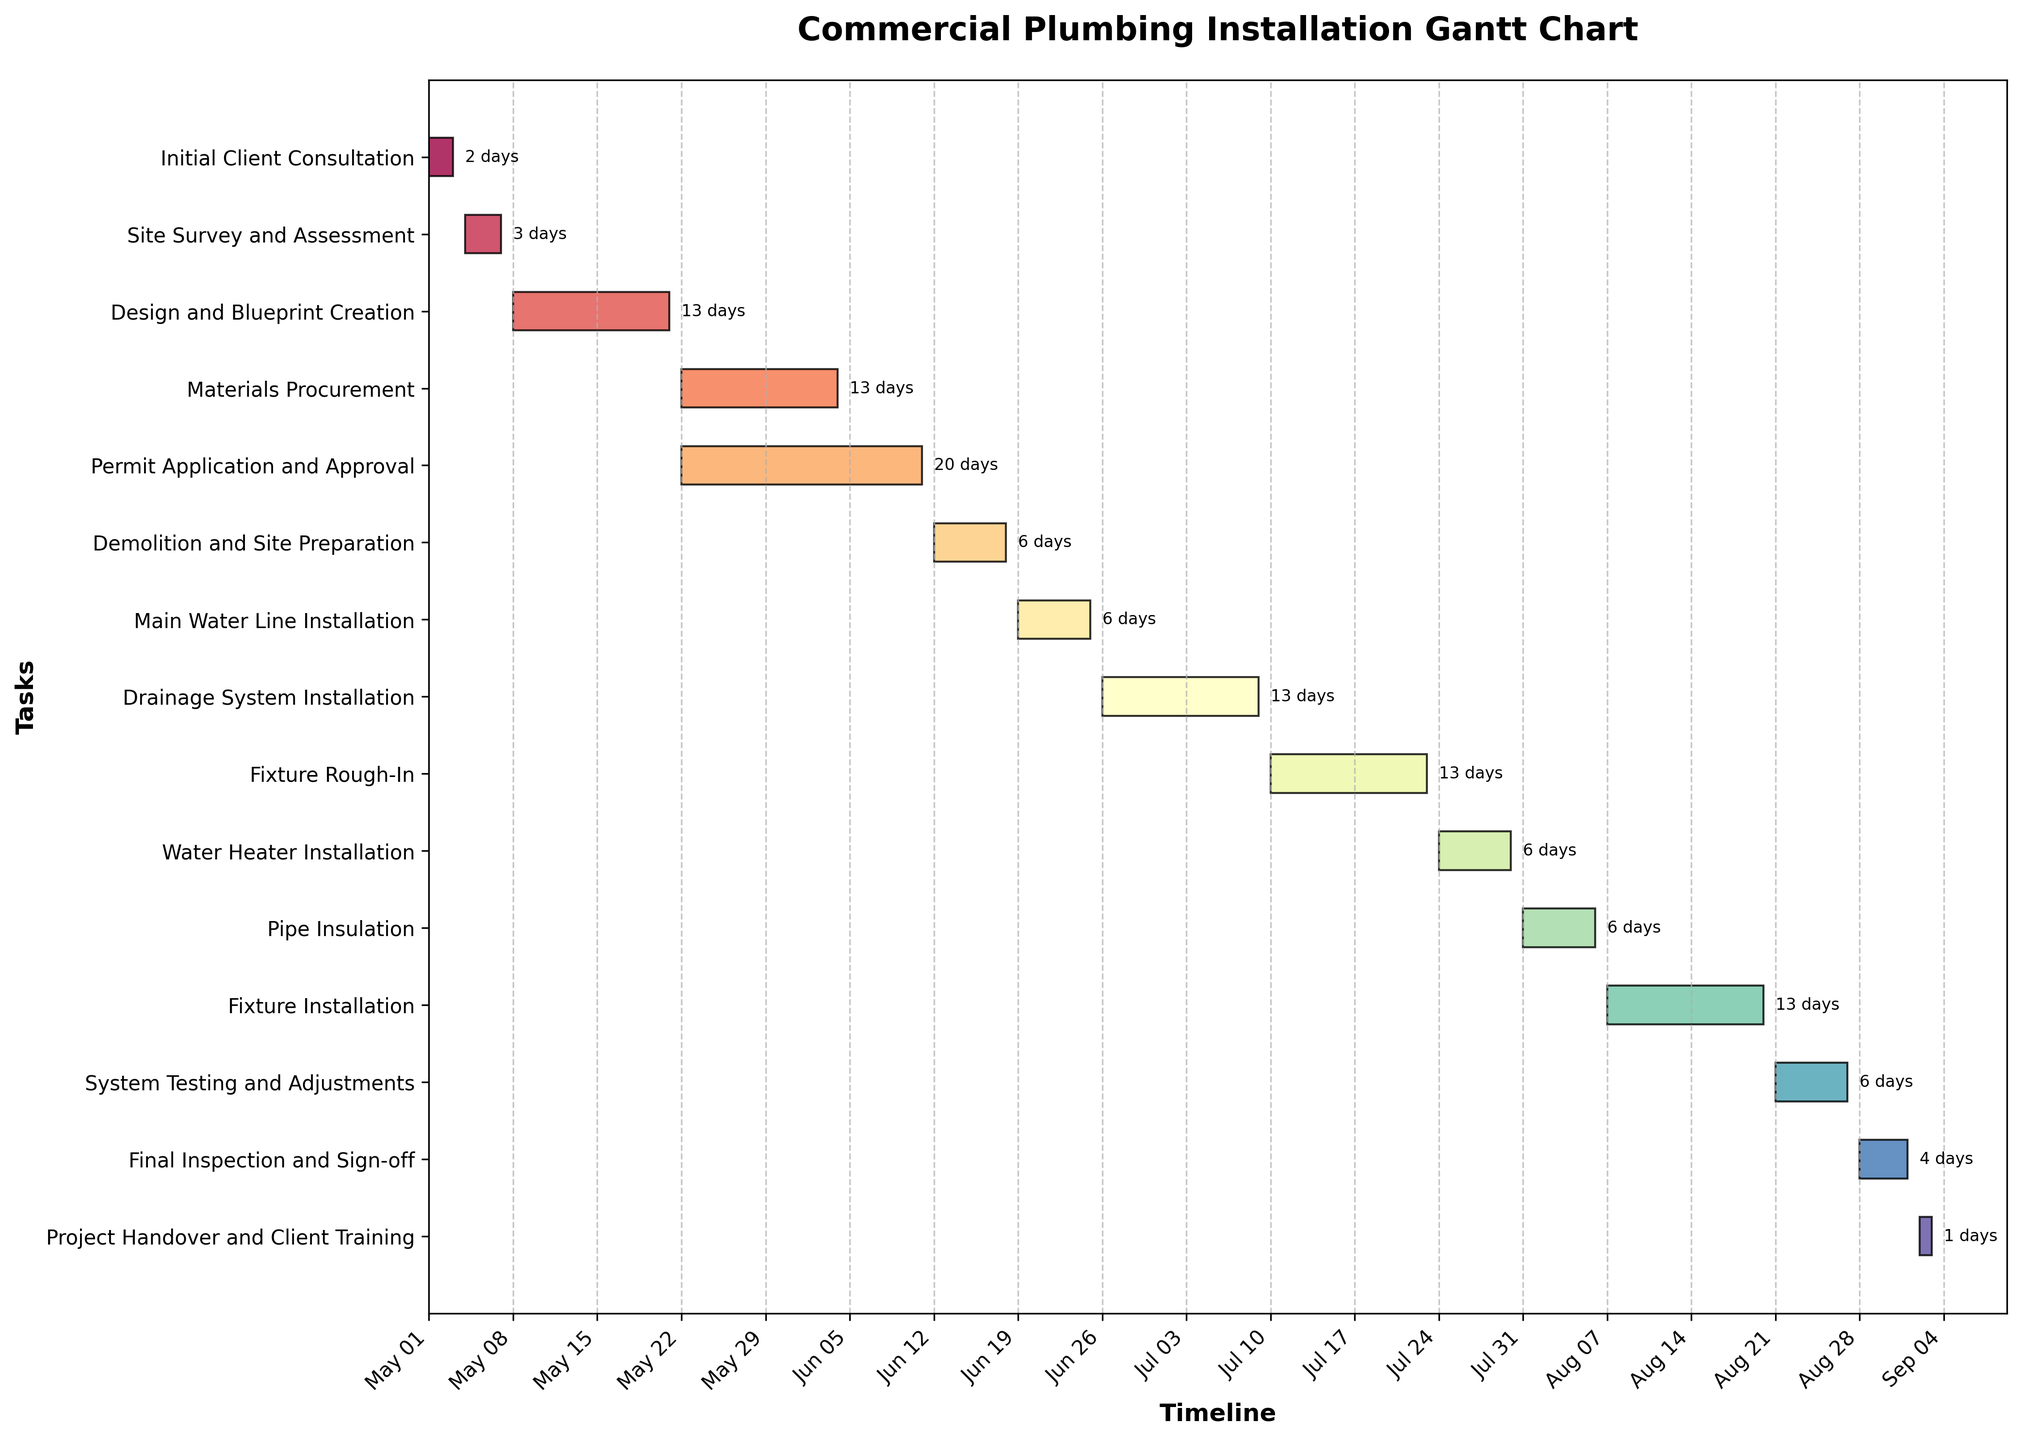When does the Main Water Line Installation start? The Main Water Line Installation task is represented on the Gantt chart, and its starting point can be identified directly from the timeline on the horizontal axis.
Answer: June 19, 2023 What is the total duration of the Project Handover and Client Training phase? The end date and the start date of the Project Handover and Client Training phase are indicated on the Gantt chart. Calculating the difference between these dates gives the total duration: Sept 3, 2023 - Sept 2, 2023 = 1 day.
Answer: 1 day Which task has the longest duration? By observing the Gantt chart, each task has a horizontal bar indicating its duration. The lengthiest bar corresponds to the Design and Blueprint Creation phase.
Answer: Design and Blueprint Creation How many days in total are spent in the Materials Procurement and Permit Application and Approval phases combined? The duration of each phase can be read directly from the chart for Materials Procurement (May 22 - June 4, 2023 = 13 days) and Permit Application and Approval (May 22 - June 11, 2023 = 20 days). Summing these gives: 13 + 20 = 33 days.
Answer: 33 days What task is scheduled to occur before the System Testing and Adjustments phase? In the Gantt chart, the horizontal bars are arranged to show the sequence of tasks. The task immediately before System Testing and Adjustments is Fixture Installation.
Answer: Fixture Installation Are there any tasks that overlap in their timelines? Checking the timeline against the start and end dates of all tasks shows some overlap. For example, Materials Procurement (May 22 - June 4, 2023) overlaps with Permit Application and Approval (May 22 - June 11, 2023).
Answer: Yes What is the last task to be completed in this project? The last task in the Gantt chart, located at the bottom of the list, is Project Handover and Client Training, ending on September 3, 2023.
Answer: Project Handover and Client Training During which month does the Demolition and Site Preparation phase take place? Referring to the start and end dates of the Demolition and Site Preparation phase in the Gantt chart shows it runs from June 12 to June 18. This falls entirely within June.
Answer: June How many days does the Final Inspection and Sign-off phase last? The start and end dates of the Final Inspection and Sign-off phase indicate the duration directly. From August 28 to September 1, 2023, the phase spans (September 1 - August 28) = 4 days.
Answer: 4 days Are there any tasks scheduled to begin on the same date? Observing the start dates of all activities in the Gantt chart, Materials Procurement and Permit Application and Approval both start on May 22, 2023.
Answer: Yes 